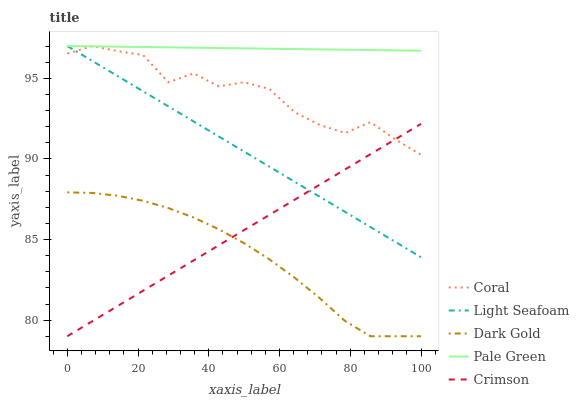Does Dark Gold have the minimum area under the curve?
Answer yes or no. Yes. Does Pale Green have the maximum area under the curve?
Answer yes or no. Yes. Does Coral have the minimum area under the curve?
Answer yes or no. No. Does Coral have the maximum area under the curve?
Answer yes or no. No. Is Crimson the smoothest?
Answer yes or no. Yes. Is Coral the roughest?
Answer yes or no. Yes. Is Pale Green the smoothest?
Answer yes or no. No. Is Pale Green the roughest?
Answer yes or no. No. Does Crimson have the lowest value?
Answer yes or no. Yes. Does Coral have the lowest value?
Answer yes or no. No. Does Light Seafoam have the highest value?
Answer yes or no. Yes. Does Dark Gold have the highest value?
Answer yes or no. No. Is Dark Gold less than Pale Green?
Answer yes or no. Yes. Is Coral greater than Dark Gold?
Answer yes or no. Yes. Does Light Seafoam intersect Pale Green?
Answer yes or no. Yes. Is Light Seafoam less than Pale Green?
Answer yes or no. No. Is Light Seafoam greater than Pale Green?
Answer yes or no. No. Does Dark Gold intersect Pale Green?
Answer yes or no. No. 